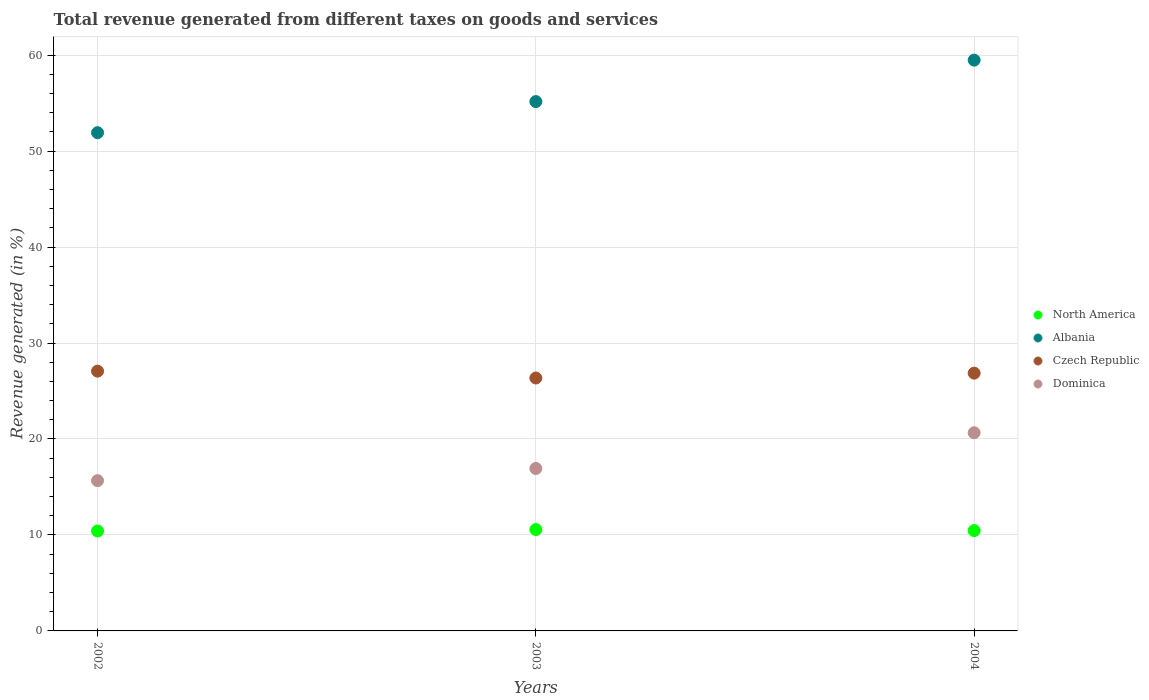How many different coloured dotlines are there?
Provide a short and direct response. 4. What is the total revenue generated in Dominica in 2004?
Keep it short and to the point. 20.65. Across all years, what is the maximum total revenue generated in North America?
Make the answer very short. 10.56. Across all years, what is the minimum total revenue generated in North America?
Keep it short and to the point. 10.41. In which year was the total revenue generated in Czech Republic maximum?
Give a very brief answer. 2002. What is the total total revenue generated in Albania in the graph?
Offer a terse response. 166.55. What is the difference between the total revenue generated in Dominica in 2002 and that in 2003?
Give a very brief answer. -1.27. What is the difference between the total revenue generated in Albania in 2002 and the total revenue generated in Czech Republic in 2003?
Offer a terse response. 25.56. What is the average total revenue generated in Czech Republic per year?
Provide a succinct answer. 26.76. In the year 2003, what is the difference between the total revenue generated in Albania and total revenue generated in Czech Republic?
Make the answer very short. 28.8. In how many years, is the total revenue generated in Albania greater than 32 %?
Keep it short and to the point. 3. What is the ratio of the total revenue generated in Dominica in 2002 to that in 2003?
Give a very brief answer. 0.93. Is the total revenue generated in Dominica in 2002 less than that in 2003?
Offer a terse response. Yes. Is the difference between the total revenue generated in Albania in 2002 and 2003 greater than the difference between the total revenue generated in Czech Republic in 2002 and 2003?
Make the answer very short. No. What is the difference between the highest and the second highest total revenue generated in Czech Republic?
Your answer should be very brief. 0.21. What is the difference between the highest and the lowest total revenue generated in Albania?
Offer a very short reply. 7.56. In how many years, is the total revenue generated in Czech Republic greater than the average total revenue generated in Czech Republic taken over all years?
Ensure brevity in your answer.  2. Is the sum of the total revenue generated in Dominica in 2003 and 2004 greater than the maximum total revenue generated in North America across all years?
Offer a very short reply. Yes. Is it the case that in every year, the sum of the total revenue generated in Czech Republic and total revenue generated in Dominica  is greater than the sum of total revenue generated in Albania and total revenue generated in North America?
Give a very brief answer. No. Is it the case that in every year, the sum of the total revenue generated in Dominica and total revenue generated in Czech Republic  is greater than the total revenue generated in North America?
Ensure brevity in your answer.  Yes. Does the total revenue generated in North America monotonically increase over the years?
Keep it short and to the point. No. How many dotlines are there?
Provide a succinct answer. 4. What is the difference between two consecutive major ticks on the Y-axis?
Ensure brevity in your answer.  10. Does the graph contain any zero values?
Provide a succinct answer. No. Does the graph contain grids?
Make the answer very short. Yes. How are the legend labels stacked?
Keep it short and to the point. Vertical. What is the title of the graph?
Your answer should be very brief. Total revenue generated from different taxes on goods and services. Does "Congo (Democratic)" appear as one of the legend labels in the graph?
Offer a very short reply. No. What is the label or title of the Y-axis?
Keep it short and to the point. Revenue generated (in %). What is the Revenue generated (in %) of North America in 2002?
Ensure brevity in your answer.  10.41. What is the Revenue generated (in %) of Albania in 2002?
Give a very brief answer. 51.92. What is the Revenue generated (in %) in Czech Republic in 2002?
Your answer should be very brief. 27.07. What is the Revenue generated (in %) in Dominica in 2002?
Your answer should be very brief. 15.66. What is the Revenue generated (in %) of North America in 2003?
Provide a short and direct response. 10.56. What is the Revenue generated (in %) of Albania in 2003?
Offer a very short reply. 55.16. What is the Revenue generated (in %) in Czech Republic in 2003?
Your response must be concise. 26.35. What is the Revenue generated (in %) of Dominica in 2003?
Keep it short and to the point. 16.93. What is the Revenue generated (in %) of North America in 2004?
Offer a very short reply. 10.45. What is the Revenue generated (in %) in Albania in 2004?
Offer a very short reply. 59.48. What is the Revenue generated (in %) of Czech Republic in 2004?
Offer a terse response. 26.86. What is the Revenue generated (in %) in Dominica in 2004?
Your response must be concise. 20.65. Across all years, what is the maximum Revenue generated (in %) in North America?
Your answer should be compact. 10.56. Across all years, what is the maximum Revenue generated (in %) of Albania?
Give a very brief answer. 59.48. Across all years, what is the maximum Revenue generated (in %) of Czech Republic?
Offer a very short reply. 27.07. Across all years, what is the maximum Revenue generated (in %) in Dominica?
Ensure brevity in your answer.  20.65. Across all years, what is the minimum Revenue generated (in %) of North America?
Provide a short and direct response. 10.41. Across all years, what is the minimum Revenue generated (in %) in Albania?
Your answer should be very brief. 51.92. Across all years, what is the minimum Revenue generated (in %) of Czech Republic?
Your answer should be very brief. 26.35. Across all years, what is the minimum Revenue generated (in %) in Dominica?
Your answer should be compact. 15.66. What is the total Revenue generated (in %) in North America in the graph?
Make the answer very short. 31.43. What is the total Revenue generated (in %) of Albania in the graph?
Provide a succinct answer. 166.55. What is the total Revenue generated (in %) of Czech Republic in the graph?
Ensure brevity in your answer.  80.28. What is the total Revenue generated (in %) in Dominica in the graph?
Your answer should be very brief. 53.24. What is the difference between the Revenue generated (in %) of North America in 2002 and that in 2003?
Provide a short and direct response. -0.15. What is the difference between the Revenue generated (in %) of Albania in 2002 and that in 2003?
Your answer should be very brief. -3.24. What is the difference between the Revenue generated (in %) in Czech Republic in 2002 and that in 2003?
Provide a short and direct response. 0.72. What is the difference between the Revenue generated (in %) of Dominica in 2002 and that in 2003?
Ensure brevity in your answer.  -1.27. What is the difference between the Revenue generated (in %) of North America in 2002 and that in 2004?
Offer a terse response. -0.04. What is the difference between the Revenue generated (in %) of Albania in 2002 and that in 2004?
Provide a short and direct response. -7.56. What is the difference between the Revenue generated (in %) of Czech Republic in 2002 and that in 2004?
Your answer should be very brief. 0.21. What is the difference between the Revenue generated (in %) in Dominica in 2002 and that in 2004?
Your answer should be very brief. -4.99. What is the difference between the Revenue generated (in %) in North America in 2003 and that in 2004?
Your response must be concise. 0.11. What is the difference between the Revenue generated (in %) of Albania in 2003 and that in 2004?
Provide a short and direct response. -4.32. What is the difference between the Revenue generated (in %) of Czech Republic in 2003 and that in 2004?
Offer a very short reply. -0.51. What is the difference between the Revenue generated (in %) in Dominica in 2003 and that in 2004?
Make the answer very short. -3.72. What is the difference between the Revenue generated (in %) in North America in 2002 and the Revenue generated (in %) in Albania in 2003?
Your answer should be compact. -44.74. What is the difference between the Revenue generated (in %) in North America in 2002 and the Revenue generated (in %) in Czech Republic in 2003?
Offer a very short reply. -15.94. What is the difference between the Revenue generated (in %) of North America in 2002 and the Revenue generated (in %) of Dominica in 2003?
Provide a short and direct response. -6.51. What is the difference between the Revenue generated (in %) in Albania in 2002 and the Revenue generated (in %) in Czech Republic in 2003?
Keep it short and to the point. 25.56. What is the difference between the Revenue generated (in %) in Albania in 2002 and the Revenue generated (in %) in Dominica in 2003?
Offer a very short reply. 34.99. What is the difference between the Revenue generated (in %) in Czech Republic in 2002 and the Revenue generated (in %) in Dominica in 2003?
Give a very brief answer. 10.14. What is the difference between the Revenue generated (in %) of North America in 2002 and the Revenue generated (in %) of Albania in 2004?
Make the answer very short. -49.06. What is the difference between the Revenue generated (in %) in North America in 2002 and the Revenue generated (in %) in Czech Republic in 2004?
Give a very brief answer. -16.45. What is the difference between the Revenue generated (in %) of North America in 2002 and the Revenue generated (in %) of Dominica in 2004?
Keep it short and to the point. -10.24. What is the difference between the Revenue generated (in %) of Albania in 2002 and the Revenue generated (in %) of Czech Republic in 2004?
Your response must be concise. 25.06. What is the difference between the Revenue generated (in %) in Albania in 2002 and the Revenue generated (in %) in Dominica in 2004?
Give a very brief answer. 31.27. What is the difference between the Revenue generated (in %) in Czech Republic in 2002 and the Revenue generated (in %) in Dominica in 2004?
Offer a terse response. 6.42. What is the difference between the Revenue generated (in %) of North America in 2003 and the Revenue generated (in %) of Albania in 2004?
Keep it short and to the point. -48.92. What is the difference between the Revenue generated (in %) in North America in 2003 and the Revenue generated (in %) in Czech Republic in 2004?
Make the answer very short. -16.3. What is the difference between the Revenue generated (in %) of North America in 2003 and the Revenue generated (in %) of Dominica in 2004?
Your response must be concise. -10.09. What is the difference between the Revenue generated (in %) in Albania in 2003 and the Revenue generated (in %) in Czech Republic in 2004?
Your answer should be compact. 28.3. What is the difference between the Revenue generated (in %) in Albania in 2003 and the Revenue generated (in %) in Dominica in 2004?
Provide a short and direct response. 34.51. What is the difference between the Revenue generated (in %) of Czech Republic in 2003 and the Revenue generated (in %) of Dominica in 2004?
Offer a terse response. 5.7. What is the average Revenue generated (in %) of North America per year?
Offer a very short reply. 10.48. What is the average Revenue generated (in %) in Albania per year?
Give a very brief answer. 55.52. What is the average Revenue generated (in %) of Czech Republic per year?
Ensure brevity in your answer.  26.76. What is the average Revenue generated (in %) in Dominica per year?
Your answer should be very brief. 17.75. In the year 2002, what is the difference between the Revenue generated (in %) in North America and Revenue generated (in %) in Albania?
Make the answer very short. -41.5. In the year 2002, what is the difference between the Revenue generated (in %) in North America and Revenue generated (in %) in Czech Republic?
Your response must be concise. -16.66. In the year 2002, what is the difference between the Revenue generated (in %) in North America and Revenue generated (in %) in Dominica?
Keep it short and to the point. -5.25. In the year 2002, what is the difference between the Revenue generated (in %) in Albania and Revenue generated (in %) in Czech Republic?
Provide a succinct answer. 24.85. In the year 2002, what is the difference between the Revenue generated (in %) in Albania and Revenue generated (in %) in Dominica?
Give a very brief answer. 36.26. In the year 2002, what is the difference between the Revenue generated (in %) in Czech Republic and Revenue generated (in %) in Dominica?
Provide a succinct answer. 11.41. In the year 2003, what is the difference between the Revenue generated (in %) of North America and Revenue generated (in %) of Albania?
Your answer should be compact. -44.59. In the year 2003, what is the difference between the Revenue generated (in %) of North America and Revenue generated (in %) of Czech Republic?
Provide a succinct answer. -15.79. In the year 2003, what is the difference between the Revenue generated (in %) in North America and Revenue generated (in %) in Dominica?
Keep it short and to the point. -6.37. In the year 2003, what is the difference between the Revenue generated (in %) of Albania and Revenue generated (in %) of Czech Republic?
Make the answer very short. 28.8. In the year 2003, what is the difference between the Revenue generated (in %) of Albania and Revenue generated (in %) of Dominica?
Provide a short and direct response. 38.23. In the year 2003, what is the difference between the Revenue generated (in %) in Czech Republic and Revenue generated (in %) in Dominica?
Your answer should be very brief. 9.43. In the year 2004, what is the difference between the Revenue generated (in %) of North America and Revenue generated (in %) of Albania?
Give a very brief answer. -49.02. In the year 2004, what is the difference between the Revenue generated (in %) of North America and Revenue generated (in %) of Czech Republic?
Keep it short and to the point. -16.41. In the year 2004, what is the difference between the Revenue generated (in %) in North America and Revenue generated (in %) in Dominica?
Your answer should be compact. -10.2. In the year 2004, what is the difference between the Revenue generated (in %) of Albania and Revenue generated (in %) of Czech Republic?
Offer a very short reply. 32.62. In the year 2004, what is the difference between the Revenue generated (in %) of Albania and Revenue generated (in %) of Dominica?
Your answer should be compact. 38.83. In the year 2004, what is the difference between the Revenue generated (in %) of Czech Republic and Revenue generated (in %) of Dominica?
Give a very brief answer. 6.21. What is the ratio of the Revenue generated (in %) in North America in 2002 to that in 2003?
Provide a short and direct response. 0.99. What is the ratio of the Revenue generated (in %) of Albania in 2002 to that in 2003?
Ensure brevity in your answer.  0.94. What is the ratio of the Revenue generated (in %) of Czech Republic in 2002 to that in 2003?
Give a very brief answer. 1.03. What is the ratio of the Revenue generated (in %) in Dominica in 2002 to that in 2003?
Your answer should be very brief. 0.93. What is the ratio of the Revenue generated (in %) in North America in 2002 to that in 2004?
Your answer should be very brief. 1. What is the ratio of the Revenue generated (in %) in Albania in 2002 to that in 2004?
Make the answer very short. 0.87. What is the ratio of the Revenue generated (in %) in Czech Republic in 2002 to that in 2004?
Ensure brevity in your answer.  1.01. What is the ratio of the Revenue generated (in %) of Dominica in 2002 to that in 2004?
Keep it short and to the point. 0.76. What is the ratio of the Revenue generated (in %) of North America in 2003 to that in 2004?
Make the answer very short. 1.01. What is the ratio of the Revenue generated (in %) in Albania in 2003 to that in 2004?
Your answer should be compact. 0.93. What is the ratio of the Revenue generated (in %) of Czech Republic in 2003 to that in 2004?
Your answer should be compact. 0.98. What is the ratio of the Revenue generated (in %) in Dominica in 2003 to that in 2004?
Ensure brevity in your answer.  0.82. What is the difference between the highest and the second highest Revenue generated (in %) of North America?
Provide a short and direct response. 0.11. What is the difference between the highest and the second highest Revenue generated (in %) of Albania?
Offer a very short reply. 4.32. What is the difference between the highest and the second highest Revenue generated (in %) of Czech Republic?
Offer a very short reply. 0.21. What is the difference between the highest and the second highest Revenue generated (in %) of Dominica?
Ensure brevity in your answer.  3.72. What is the difference between the highest and the lowest Revenue generated (in %) of North America?
Offer a very short reply. 0.15. What is the difference between the highest and the lowest Revenue generated (in %) in Albania?
Provide a short and direct response. 7.56. What is the difference between the highest and the lowest Revenue generated (in %) in Czech Republic?
Your answer should be very brief. 0.72. What is the difference between the highest and the lowest Revenue generated (in %) of Dominica?
Offer a very short reply. 4.99. 